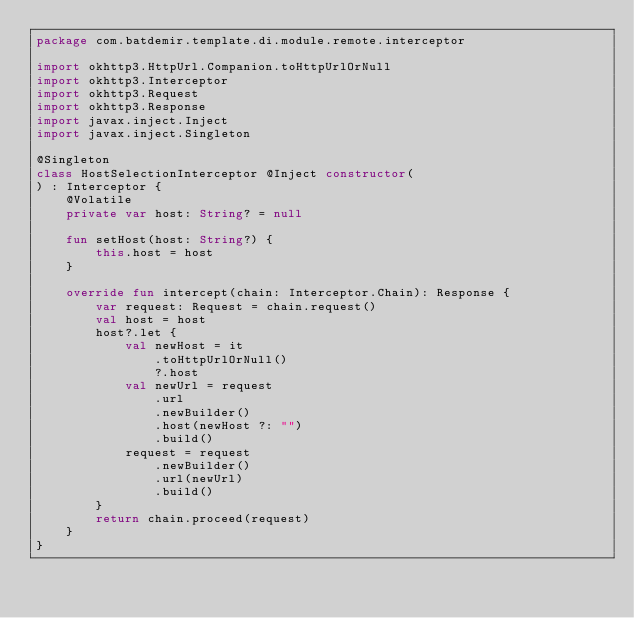Convert code to text. <code><loc_0><loc_0><loc_500><loc_500><_Kotlin_>package com.batdemir.template.di.module.remote.interceptor

import okhttp3.HttpUrl.Companion.toHttpUrlOrNull
import okhttp3.Interceptor
import okhttp3.Request
import okhttp3.Response
import javax.inject.Inject
import javax.inject.Singleton

@Singleton
class HostSelectionInterceptor @Inject constructor(
) : Interceptor {
    @Volatile
    private var host: String? = null

    fun setHost(host: String?) {
        this.host = host
    }

    override fun intercept(chain: Interceptor.Chain): Response {
        var request: Request = chain.request()
        val host = host
        host?.let {
            val newHost = it
                .toHttpUrlOrNull()
                ?.host
            val newUrl = request
                .url
                .newBuilder()
                .host(newHost ?: "")
                .build()
            request = request
                .newBuilder()
                .url(newUrl)
                .build()
        }
        return chain.proceed(request)
    }
}</code> 